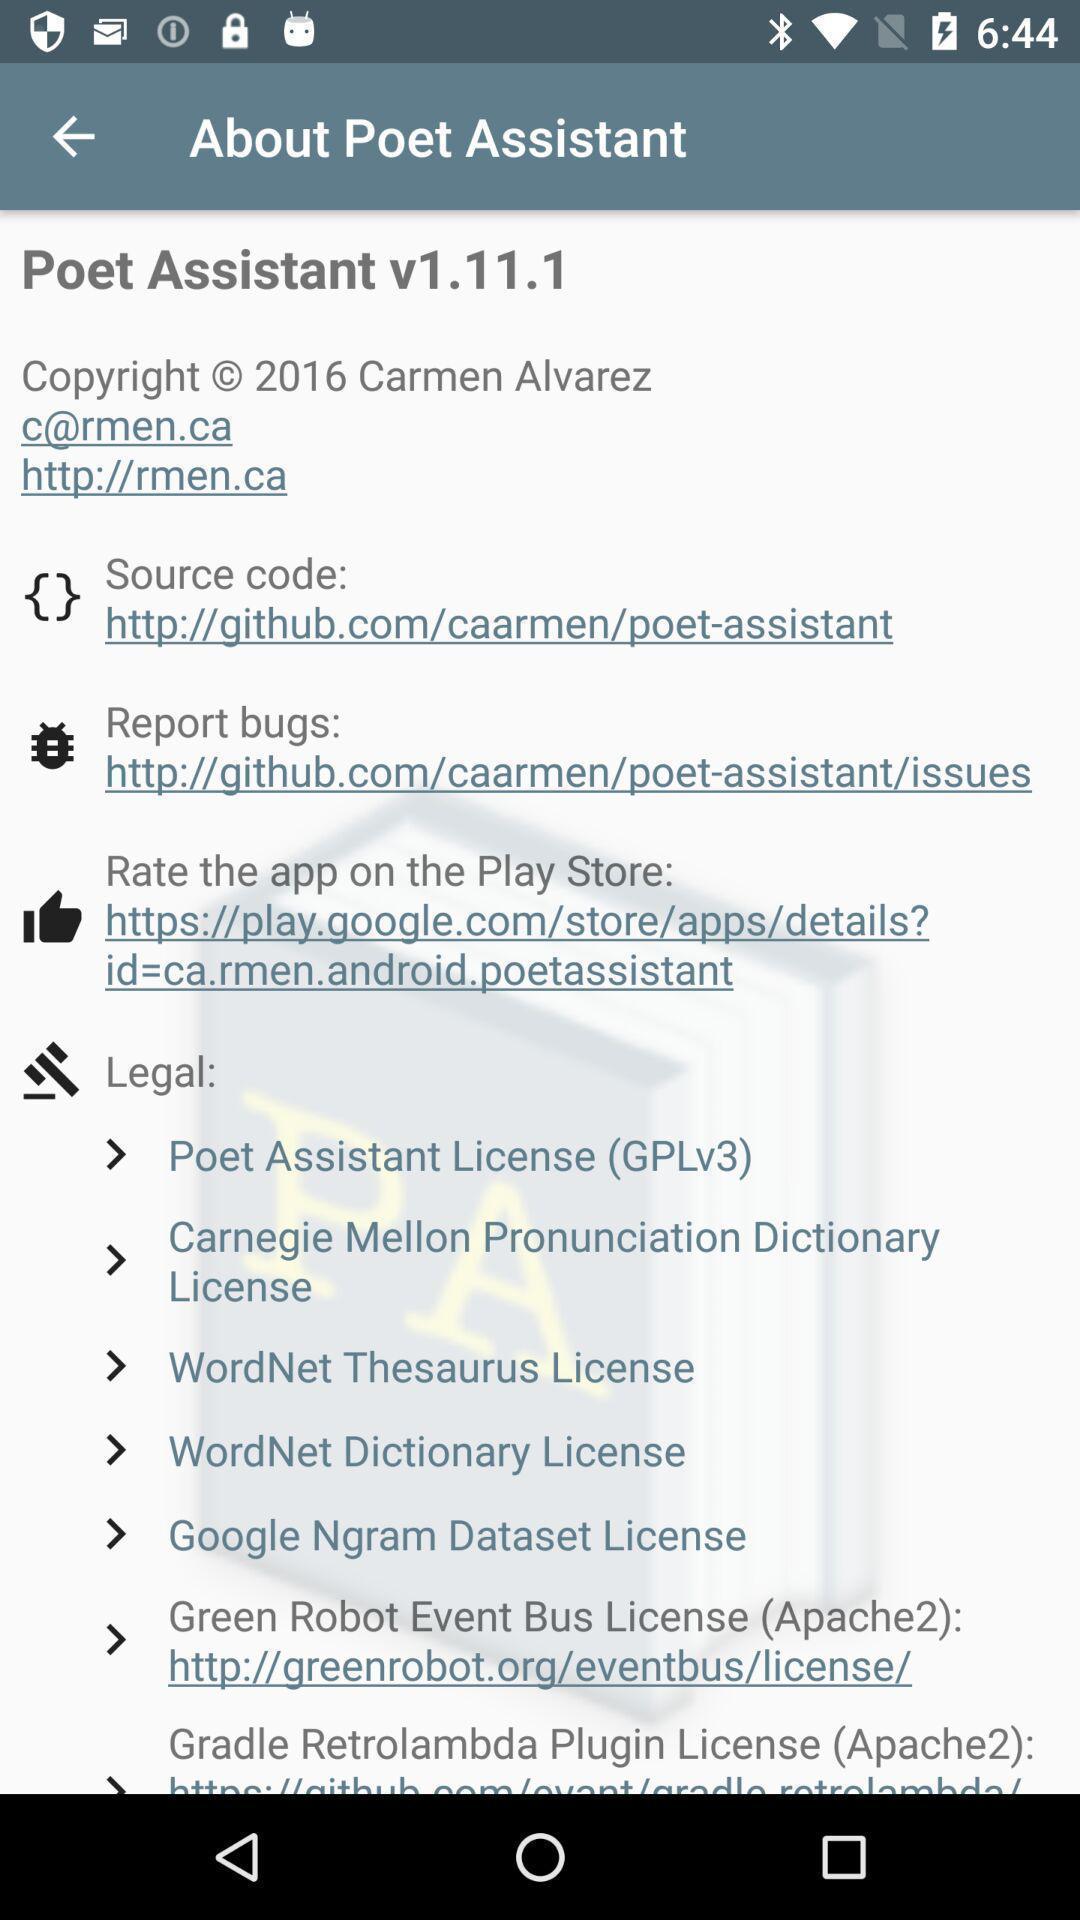Provide a description of this screenshot. Page displaying various information in learning application. 